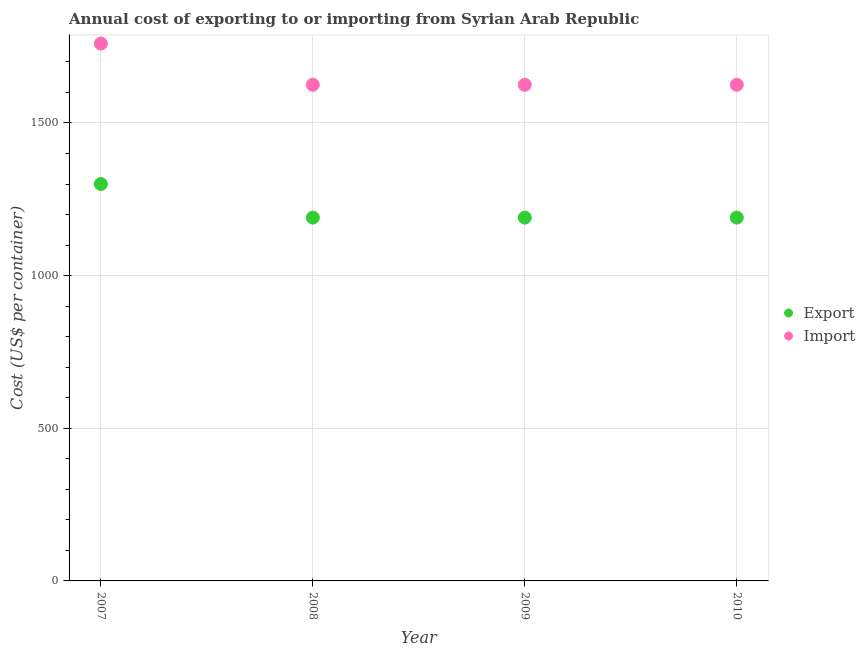How many different coloured dotlines are there?
Offer a terse response. 2. What is the import cost in 2010?
Make the answer very short. 1625. Across all years, what is the maximum export cost?
Your answer should be compact. 1300. Across all years, what is the minimum export cost?
Offer a very short reply. 1190. In which year was the import cost maximum?
Your answer should be very brief. 2007. What is the total export cost in the graph?
Provide a short and direct response. 4870. What is the difference between the import cost in 2007 and that in 2008?
Keep it short and to the point. 135. What is the difference between the export cost in 2009 and the import cost in 2008?
Keep it short and to the point. -435. What is the average import cost per year?
Give a very brief answer. 1658.75. In the year 2007, what is the difference between the import cost and export cost?
Make the answer very short. 460. In how many years, is the import cost greater than 1000 US$?
Your response must be concise. 4. What is the difference between the highest and the second highest export cost?
Provide a succinct answer. 110. What is the difference between the highest and the lowest import cost?
Provide a succinct answer. 135. In how many years, is the import cost greater than the average import cost taken over all years?
Your answer should be compact. 1. Is the export cost strictly greater than the import cost over the years?
Provide a succinct answer. No. Is the import cost strictly less than the export cost over the years?
Your response must be concise. No. How many dotlines are there?
Give a very brief answer. 2. How many years are there in the graph?
Offer a terse response. 4. How many legend labels are there?
Offer a very short reply. 2. How are the legend labels stacked?
Your answer should be compact. Vertical. What is the title of the graph?
Keep it short and to the point. Annual cost of exporting to or importing from Syrian Arab Republic. What is the label or title of the X-axis?
Keep it short and to the point. Year. What is the label or title of the Y-axis?
Give a very brief answer. Cost (US$ per container). What is the Cost (US$ per container) in Export in 2007?
Make the answer very short. 1300. What is the Cost (US$ per container) in Import in 2007?
Offer a very short reply. 1760. What is the Cost (US$ per container) in Export in 2008?
Your response must be concise. 1190. What is the Cost (US$ per container) in Import in 2008?
Provide a short and direct response. 1625. What is the Cost (US$ per container) in Export in 2009?
Provide a succinct answer. 1190. What is the Cost (US$ per container) of Import in 2009?
Offer a terse response. 1625. What is the Cost (US$ per container) in Export in 2010?
Offer a very short reply. 1190. What is the Cost (US$ per container) in Import in 2010?
Ensure brevity in your answer.  1625. Across all years, what is the maximum Cost (US$ per container) of Export?
Make the answer very short. 1300. Across all years, what is the maximum Cost (US$ per container) in Import?
Provide a succinct answer. 1760. Across all years, what is the minimum Cost (US$ per container) in Export?
Provide a succinct answer. 1190. Across all years, what is the minimum Cost (US$ per container) of Import?
Make the answer very short. 1625. What is the total Cost (US$ per container) in Export in the graph?
Ensure brevity in your answer.  4870. What is the total Cost (US$ per container) of Import in the graph?
Give a very brief answer. 6635. What is the difference between the Cost (US$ per container) of Export in 2007 and that in 2008?
Offer a terse response. 110. What is the difference between the Cost (US$ per container) in Import in 2007 and that in 2008?
Offer a very short reply. 135. What is the difference between the Cost (US$ per container) in Export in 2007 and that in 2009?
Offer a very short reply. 110. What is the difference between the Cost (US$ per container) in Import in 2007 and that in 2009?
Your response must be concise. 135. What is the difference between the Cost (US$ per container) in Export in 2007 and that in 2010?
Your response must be concise. 110. What is the difference between the Cost (US$ per container) in Import in 2007 and that in 2010?
Your answer should be compact. 135. What is the difference between the Cost (US$ per container) of Export in 2008 and that in 2009?
Your answer should be very brief. 0. What is the difference between the Cost (US$ per container) of Import in 2008 and that in 2009?
Offer a terse response. 0. What is the difference between the Cost (US$ per container) in Export in 2008 and that in 2010?
Ensure brevity in your answer.  0. What is the difference between the Cost (US$ per container) in Import in 2008 and that in 2010?
Your answer should be very brief. 0. What is the difference between the Cost (US$ per container) in Export in 2007 and the Cost (US$ per container) in Import in 2008?
Offer a terse response. -325. What is the difference between the Cost (US$ per container) of Export in 2007 and the Cost (US$ per container) of Import in 2009?
Offer a very short reply. -325. What is the difference between the Cost (US$ per container) of Export in 2007 and the Cost (US$ per container) of Import in 2010?
Keep it short and to the point. -325. What is the difference between the Cost (US$ per container) in Export in 2008 and the Cost (US$ per container) in Import in 2009?
Provide a short and direct response. -435. What is the difference between the Cost (US$ per container) in Export in 2008 and the Cost (US$ per container) in Import in 2010?
Your answer should be compact. -435. What is the difference between the Cost (US$ per container) in Export in 2009 and the Cost (US$ per container) in Import in 2010?
Offer a very short reply. -435. What is the average Cost (US$ per container) in Export per year?
Provide a succinct answer. 1217.5. What is the average Cost (US$ per container) of Import per year?
Ensure brevity in your answer.  1658.75. In the year 2007, what is the difference between the Cost (US$ per container) in Export and Cost (US$ per container) in Import?
Offer a terse response. -460. In the year 2008, what is the difference between the Cost (US$ per container) of Export and Cost (US$ per container) of Import?
Your answer should be compact. -435. In the year 2009, what is the difference between the Cost (US$ per container) in Export and Cost (US$ per container) in Import?
Ensure brevity in your answer.  -435. In the year 2010, what is the difference between the Cost (US$ per container) in Export and Cost (US$ per container) in Import?
Your response must be concise. -435. What is the ratio of the Cost (US$ per container) of Export in 2007 to that in 2008?
Offer a very short reply. 1.09. What is the ratio of the Cost (US$ per container) in Import in 2007 to that in 2008?
Offer a terse response. 1.08. What is the ratio of the Cost (US$ per container) in Export in 2007 to that in 2009?
Make the answer very short. 1.09. What is the ratio of the Cost (US$ per container) in Import in 2007 to that in 2009?
Provide a short and direct response. 1.08. What is the ratio of the Cost (US$ per container) in Export in 2007 to that in 2010?
Your answer should be compact. 1.09. What is the ratio of the Cost (US$ per container) in Import in 2007 to that in 2010?
Provide a succinct answer. 1.08. What is the ratio of the Cost (US$ per container) of Export in 2008 to that in 2009?
Make the answer very short. 1. What is the ratio of the Cost (US$ per container) in Import in 2008 to that in 2009?
Your answer should be compact. 1. What is the ratio of the Cost (US$ per container) of Import in 2008 to that in 2010?
Your answer should be very brief. 1. What is the difference between the highest and the second highest Cost (US$ per container) in Export?
Keep it short and to the point. 110. What is the difference between the highest and the second highest Cost (US$ per container) of Import?
Offer a very short reply. 135. What is the difference between the highest and the lowest Cost (US$ per container) in Export?
Give a very brief answer. 110. What is the difference between the highest and the lowest Cost (US$ per container) in Import?
Make the answer very short. 135. 